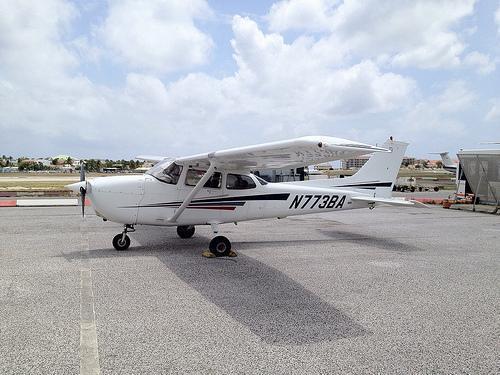How many propellers does the plane have?
Give a very brief answer. 1. 